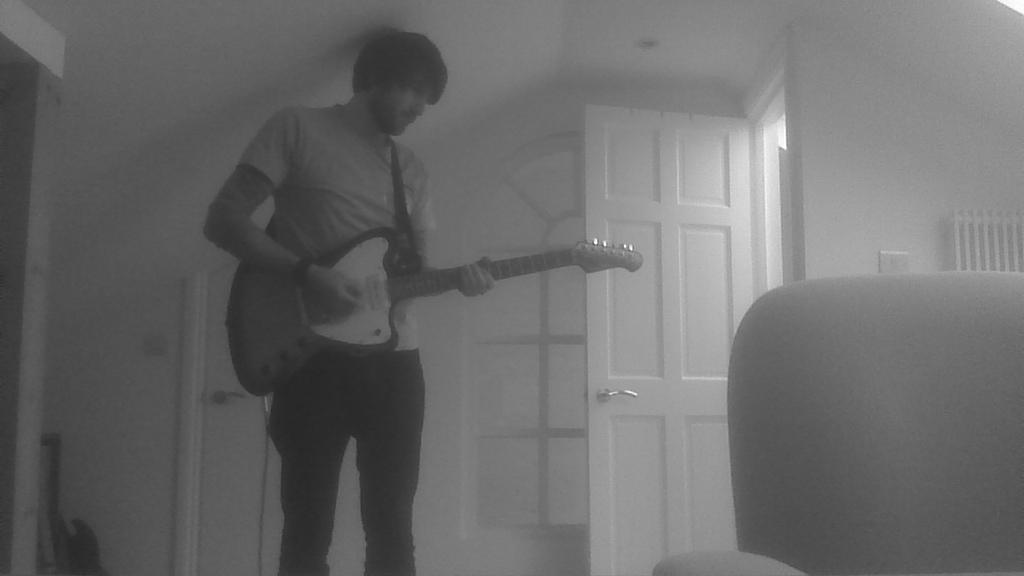What is the man in the image doing? The man is playing a guitar. How is the man positioned in the image? The man is standing. What other objects can be seen in the image besides the man? There is a chair, a guitar in the corner, a door, and a door handle in the image. What type of card is the man holding in the image? There is no card present in the image. Can you describe the mother in the image? There is no mention of a mother in the image; it only features a man playing a guitar. 